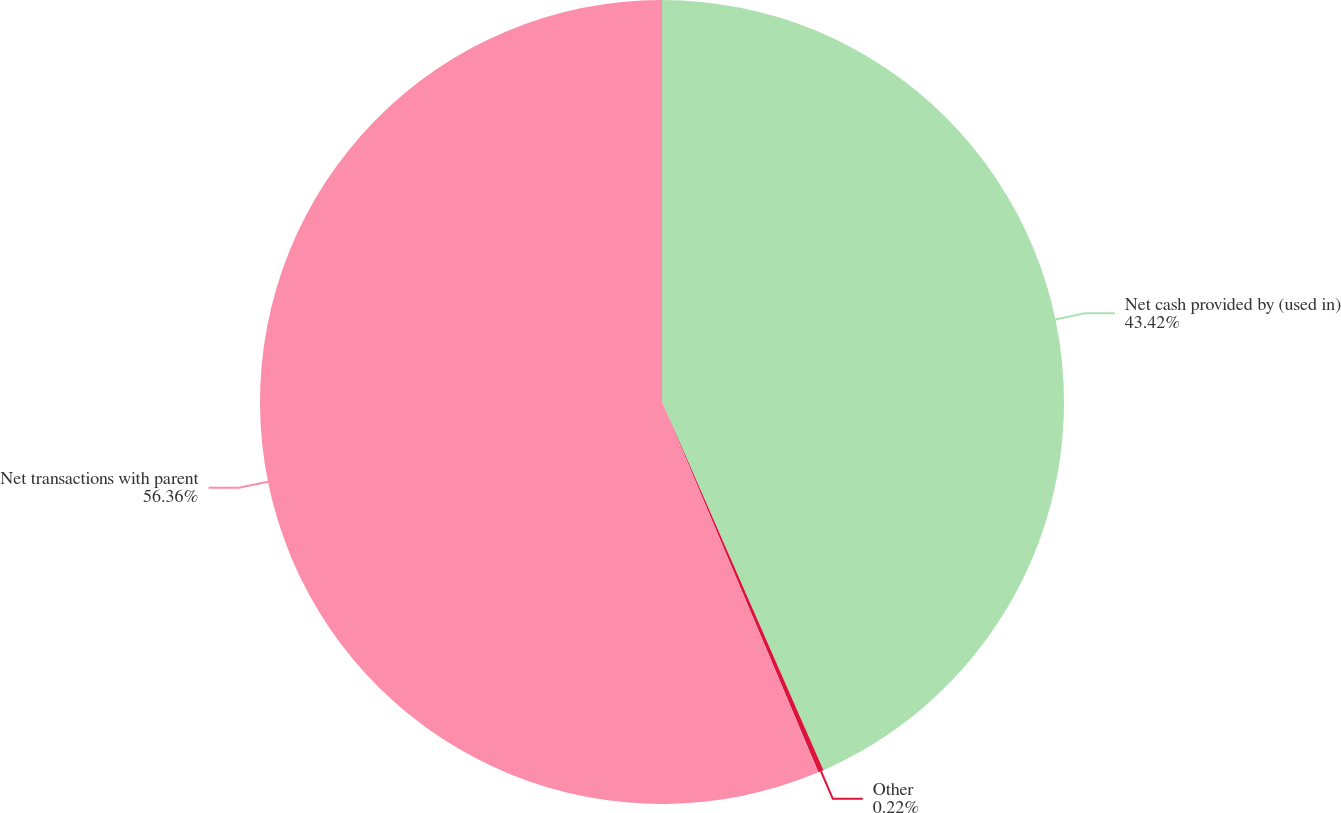Convert chart to OTSL. <chart><loc_0><loc_0><loc_500><loc_500><pie_chart><fcel>Net cash provided by (used in)<fcel>Other<fcel>Net transactions with parent<nl><fcel>43.42%<fcel>0.22%<fcel>56.36%<nl></chart> 